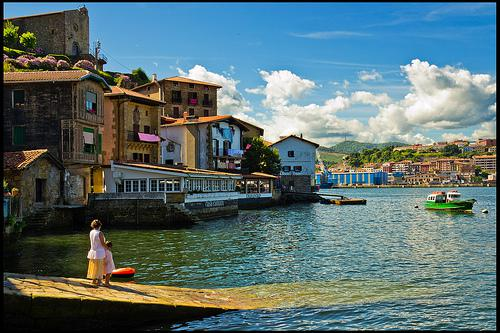Question: what is built on the water?
Choices:
A. Horses.
B. Houses.
C. Piers.
D. Boats.
Answer with the letter. Answer: B Question: who is standing in front of lady with white shirt on the boat ramp?
Choices:
A. A little girl.
B. A big girl.
C. A boy.
D. A little child.
Answer with the letter. Answer: D 